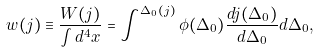Convert formula to latex. <formula><loc_0><loc_0><loc_500><loc_500>w ( j ) \equiv \frac { W ( j ) } { \int d ^ { 4 } x } = \int ^ { \Delta _ { 0 } ( j ) } \phi ( \Delta _ { 0 } ) \frac { d j ( \Delta _ { 0 } ) } { d \Delta _ { 0 } } d \Delta _ { 0 } ,</formula> 